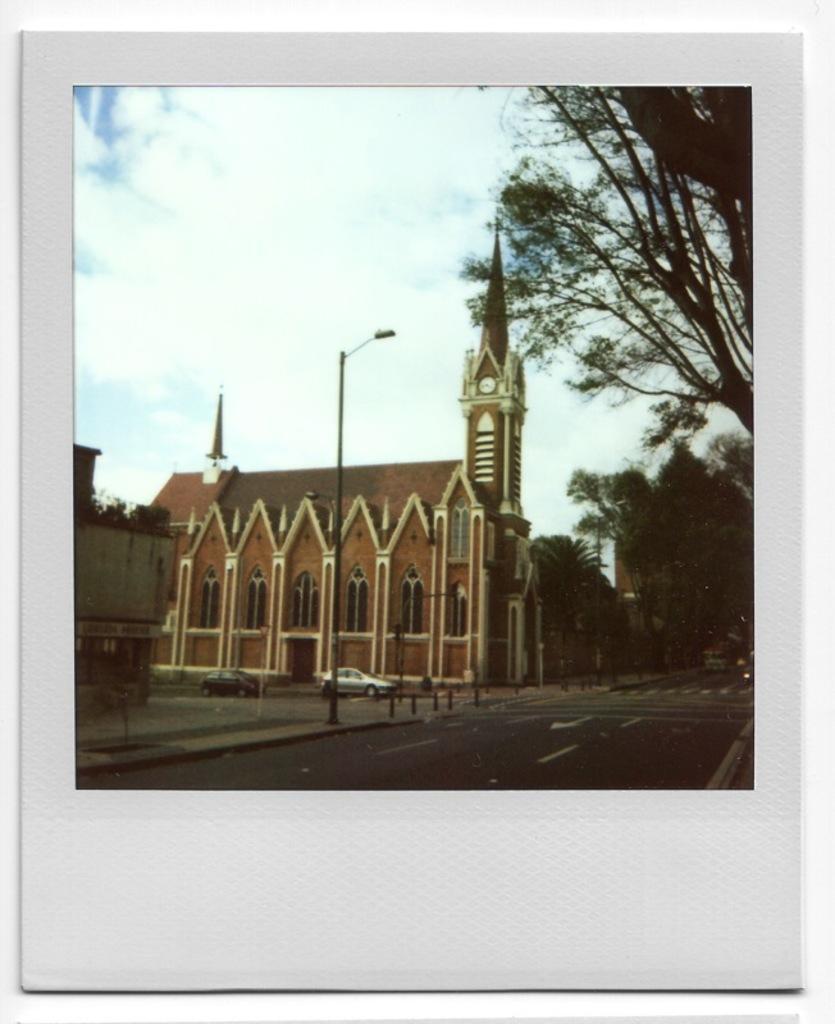Can you describe this image briefly? In the picture we can see a photograph of the church building beside it, we can see another building and near to it, we can see a pole with light to it and on the other side we can see some trees and behind it we can see the sky with clouds. 